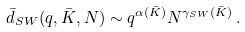Convert formula to latex. <formula><loc_0><loc_0><loc_500><loc_500>\bar { d } _ { S W } ( q , \bar { K } , N ) \sim q ^ { \alpha ( \bar { K } ) } N ^ { \gamma _ { S W } ( \bar { K } ) } \, .</formula> 